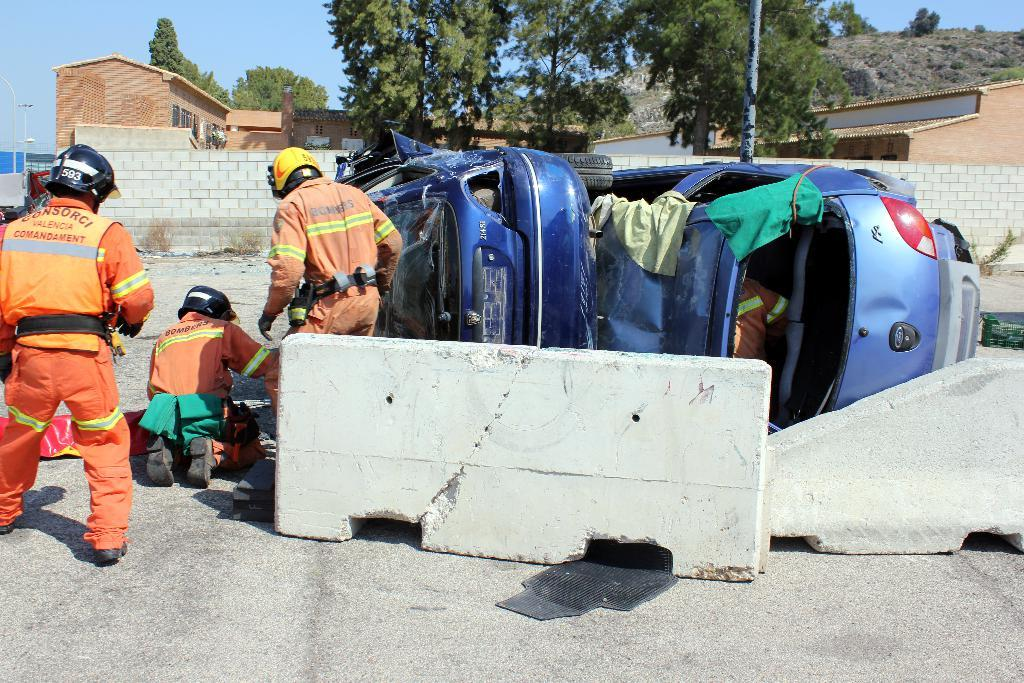How many people are wearing helmets in the image? There are three people wearing helmets on the left side of the image. What can be seen near the people wearing helmets? There are barricades near the people. What else is present in the image besides the people and barricades? There are vehicles in the image. What can be seen in the background of the image? There is a wall, buildings, trees, and the sky visible in the background of the image. What type of berry can be seen growing on the wall in the image? There are no berries visible in the image, and the wall is not described as having any vegetation. 